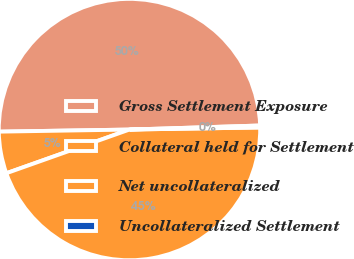Convert chart to OTSL. <chart><loc_0><loc_0><loc_500><loc_500><pie_chart><fcel>Gross Settlement Exposure<fcel>Collateral held for Settlement<fcel>Net uncollateralized<fcel>Uncollateralized Settlement<nl><fcel>49.76%<fcel>5.17%<fcel>44.83%<fcel>0.24%<nl></chart> 